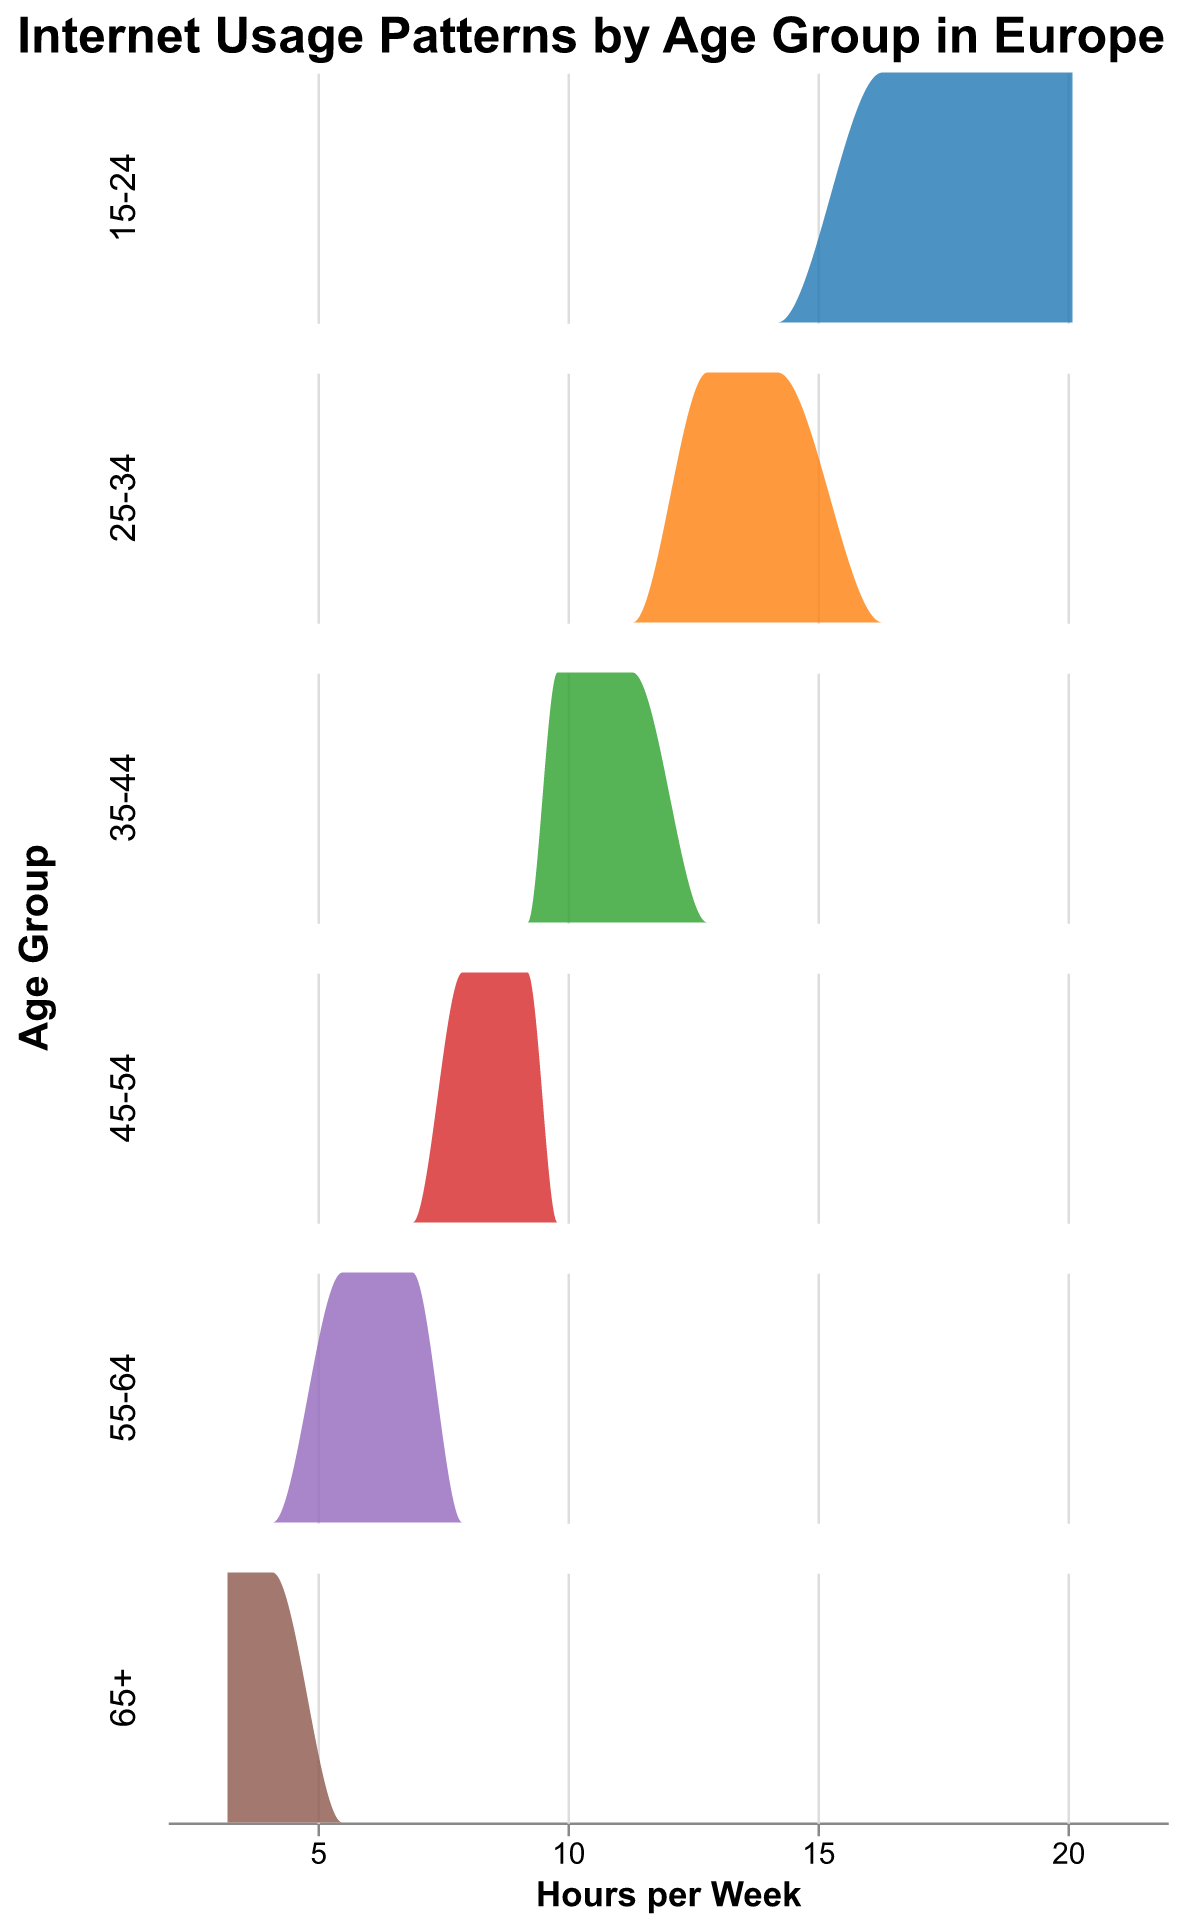What is the title of the figure? The title is placed at the top of the figure, usually in a larger font size. It provides a general understanding of what the figure is about.
Answer: Internet Usage Patterns by Age Group in Europe What age group shows the highest density of Internet usage per week? By observing the density plots, the age group with the tallest peak represents the highest density, indicating more data points with similar usage hours.
Answer: 15-24 Which age group has the least Internet usage per week on average? By looking at the x-axis (hours per week) and comparing the density plots, the age group with the lowest average hours of internet usage is easily identified.
Answer: 65+ What is the range of Internet usage hours per week for the 25-34 age group? The range can be seen by identifying the spread of the density plot on the x-axis for the 25-34 age group.
Answer: 12.8 to 14.2 hours Which age group displays the widest range of hours per week for Internet usage? The age group with the widest density plot along the x-axis indicates the largest range of hours per week for Internet usage.
Answer: 25-34 Compare the internet usage between the 35-44 and 45-54 age groups. Which group spends more hours online per week? To compare, look at the peaks and spread of both density plots; the age group with the higher peak or farther spread to the right spends more time online.
Answer: 35-44 Does any age group show a significant overlap in their density plots of Internet usage with another age group? Look for overlapping areas between different colored density plots; overlapping regions indicate similar usage patterns.
Answer: Yes, 15-24 and 25-34 What can be inferred about the Internet usage trend as age increases? Observing the shift of the density plots, one can infer trends by how density plots move left or right along the x-axis or how their heights change.
Answer: Decreases What is the median Internet usage hours per week for the 45-54 age group? Calculate the median by finding the middle value of hours which corresponds to the peak of the density plot for that age group.
Answer: 8.4 hours How does internet usage vary between the youngest and oldest age groups? Compare the density plots of the 15-24 and 65+ age groups, focusing on the spread and height of the plots on the x-axis.
Answer: Youngest uses much more 